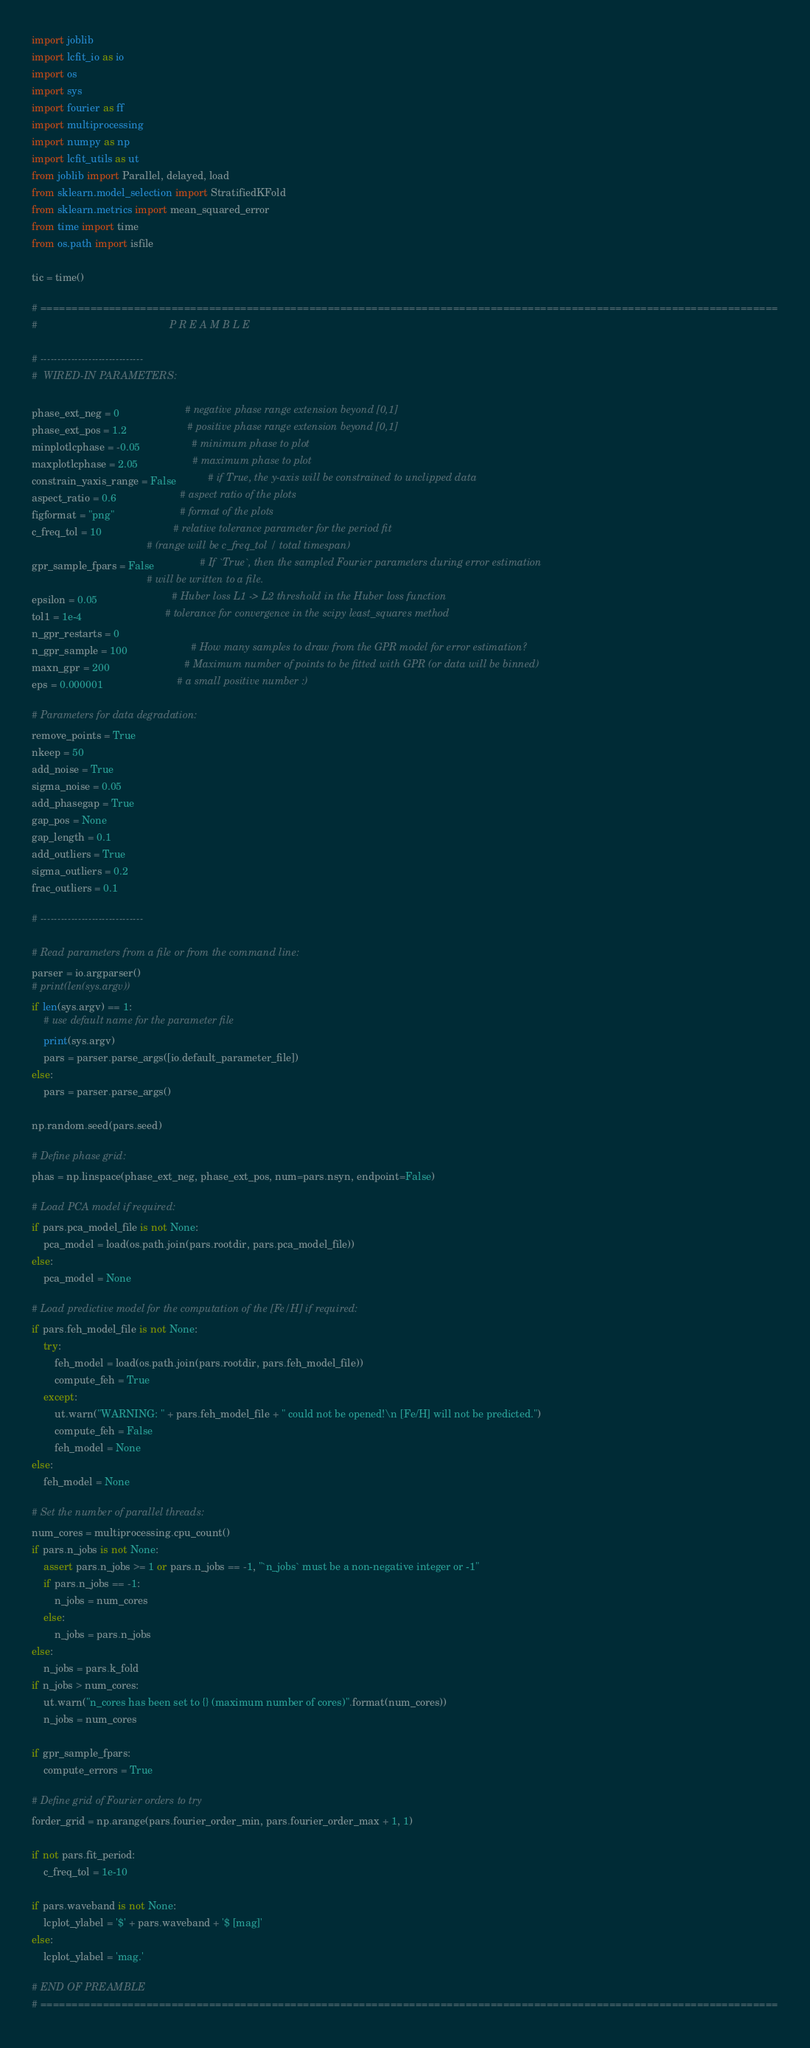<code> <loc_0><loc_0><loc_500><loc_500><_Python_>import joblib
import lcfit_io as io
import os
import sys
import fourier as ff
import multiprocessing
import numpy as np
import lcfit_utils as ut
from joblib import Parallel, delayed, load
from sklearn.model_selection import StratifiedKFold
from sklearn.metrics import mean_squared_error
from time import time
from os.path import isfile

tic = time()

# ======================================================================================================================
#                                              P R E A M B L E

# ------------------------------
#  WIRED-IN PARAMETERS:

phase_ext_neg = 0                       # negative phase range extension beyond [0,1]
phase_ext_pos = 1.2                     # positive phase range extension beyond [0,1]
minplotlcphase = -0.05                  # minimum phase to plot
maxplotlcphase = 2.05                   # maximum phase to plot
constrain_yaxis_range = False           # if True, the y-axis will be constrained to unclipped data
aspect_ratio = 0.6                      # aspect ratio of the plots
figformat = "png"                       # format of the plots
c_freq_tol = 10                         # relative tolerance parameter for the period fit
                                        # (range will be c_freq_tol / total timespan)
gpr_sample_fpars = False                # If `True`, then the sampled Fourier parameters during error estimation
                                        # will be written to a file.
epsilon = 0.05                          # Huber loss L1 -> L2 threshold in the Huber loss function
tol1 = 1e-4                             # tolerance for convergence in the scipy least_squares method
n_gpr_restarts = 0
n_gpr_sample = 100                      # How many samples to draw from the GPR model for error estimation?
maxn_gpr = 200                          # Maximum number of points to be fitted with GPR (or data will be binned)
eps = 0.000001                          # a small positive number :)

# Parameters for data degradation:
remove_points = True
nkeep = 50
add_noise = True
sigma_noise = 0.05
add_phasegap = True
gap_pos = None
gap_length = 0.1
add_outliers = True
sigma_outliers = 0.2
frac_outliers = 0.1

# ------------------------------

# Read parameters from a file or from the command line:
parser = io.argparser()
# print(len(sys.argv))
if len(sys.argv) == 1:
    # use default name for the parameter file
    print(sys.argv)
    pars = parser.parse_args([io.default_parameter_file])
else:
    pars = parser.parse_args()

np.random.seed(pars.seed)

# Define phase grid:
phas = np.linspace(phase_ext_neg, phase_ext_pos, num=pars.nsyn, endpoint=False)

# Load PCA model if required:
if pars.pca_model_file is not None:
    pca_model = load(os.path.join(pars.rootdir, pars.pca_model_file))
else:
    pca_model = None

# Load predictive model for the computation of the [Fe/H] if required:
if pars.feh_model_file is not None:
    try:
        feh_model = load(os.path.join(pars.rootdir, pars.feh_model_file))
        compute_feh = True
    except:
        ut.warn("WARNING: " + pars.feh_model_file + " could not be opened!\n [Fe/H] will not be predicted.")
        compute_feh = False
        feh_model = None
else:
    feh_model = None

# Set the number of parallel threads:
num_cores = multiprocessing.cpu_count()
if pars.n_jobs is not None:
    assert pars.n_jobs >= 1 or pars.n_jobs == -1, "`n_jobs` must be a non-negative integer or -1"
    if pars.n_jobs == -1:
        n_jobs = num_cores
    else:
        n_jobs = pars.n_jobs
else:
    n_jobs = pars.k_fold
if n_jobs > num_cores:
    ut.warn("n_cores has been set to {} (maximum number of cores)".format(num_cores))
    n_jobs = num_cores

if gpr_sample_fpars:
    compute_errors = True

# Define grid of Fourier orders to try
forder_grid = np.arange(pars.fourier_order_min, pars.fourier_order_max + 1, 1)

if not pars.fit_period:
    c_freq_tol = 1e-10

if pars.waveband is not None:
    lcplot_ylabel = '$' + pars.waveband + '$ [mag]'
else:
    lcplot_ylabel = 'mag.'

# END OF PREAMBLE
# ======================================================================================================================

</code> 